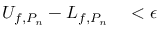Convert formula to latex. <formula><loc_0><loc_0><loc_500><loc_500>\begin{array} { r l } { U _ { f , P _ { n } } - L _ { f , P _ { n } } } & < \epsilon } \end{array}</formula> 